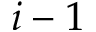Convert formula to latex. <formula><loc_0><loc_0><loc_500><loc_500>i - 1</formula> 